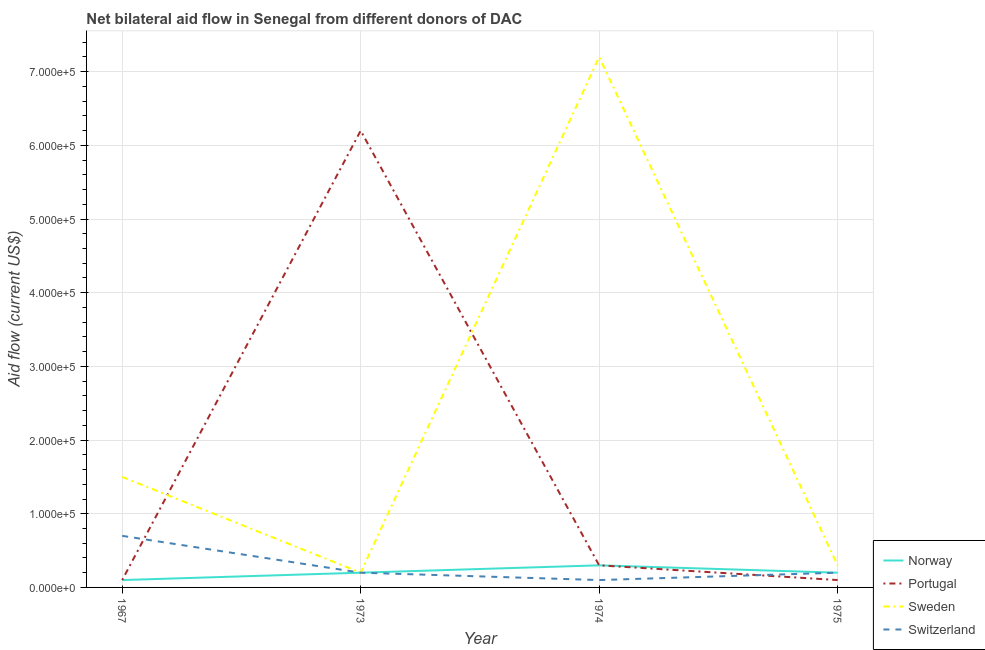What is the amount of aid given by sweden in 1975?
Provide a short and direct response. 3.00e+04. Across all years, what is the maximum amount of aid given by sweden?
Your response must be concise. 7.20e+05. Across all years, what is the minimum amount of aid given by sweden?
Your answer should be compact. 2.00e+04. In which year was the amount of aid given by norway maximum?
Your response must be concise. 1974. In which year was the amount of aid given by switzerland minimum?
Your answer should be very brief. 1974. What is the total amount of aid given by switzerland in the graph?
Provide a succinct answer. 1.20e+05. What is the difference between the amount of aid given by switzerland in 1973 and that in 1975?
Make the answer very short. 0. What is the difference between the amount of aid given by norway in 1967 and the amount of aid given by switzerland in 1975?
Ensure brevity in your answer.  -10000. In the year 1975, what is the difference between the amount of aid given by sweden and amount of aid given by switzerland?
Give a very brief answer. 10000. What is the ratio of the amount of aid given by sweden in 1967 to that in 1973?
Keep it short and to the point. 7.5. Is the amount of aid given by sweden in 1967 less than that in 1974?
Offer a terse response. Yes. Is the difference between the amount of aid given by portugal in 1967 and 1975 greater than the difference between the amount of aid given by norway in 1967 and 1975?
Provide a short and direct response. Yes. What is the difference between the highest and the second highest amount of aid given by switzerland?
Your answer should be very brief. 5.00e+04. What is the difference between the highest and the lowest amount of aid given by sweden?
Your response must be concise. 7.00e+05. Is it the case that in every year, the sum of the amount of aid given by sweden and amount of aid given by portugal is greater than the sum of amount of aid given by switzerland and amount of aid given by norway?
Offer a terse response. Yes. Is it the case that in every year, the sum of the amount of aid given by norway and amount of aid given by portugal is greater than the amount of aid given by sweden?
Provide a succinct answer. No. Is the amount of aid given by portugal strictly greater than the amount of aid given by norway over the years?
Your answer should be very brief. No. Is the amount of aid given by switzerland strictly less than the amount of aid given by portugal over the years?
Make the answer very short. No. How many lines are there?
Offer a very short reply. 4. What is the difference between two consecutive major ticks on the Y-axis?
Offer a terse response. 1.00e+05. Are the values on the major ticks of Y-axis written in scientific E-notation?
Your answer should be very brief. Yes. Does the graph contain grids?
Your response must be concise. Yes. Where does the legend appear in the graph?
Offer a terse response. Bottom right. How many legend labels are there?
Ensure brevity in your answer.  4. How are the legend labels stacked?
Make the answer very short. Vertical. What is the title of the graph?
Offer a very short reply. Net bilateral aid flow in Senegal from different donors of DAC. What is the label or title of the Y-axis?
Your answer should be very brief. Aid flow (current US$). What is the Aid flow (current US$) of Norway in 1967?
Make the answer very short. 10000. What is the Aid flow (current US$) in Sweden in 1967?
Give a very brief answer. 1.50e+05. What is the Aid flow (current US$) in Norway in 1973?
Offer a very short reply. 2.00e+04. What is the Aid flow (current US$) in Portugal in 1973?
Your response must be concise. 6.20e+05. What is the Aid flow (current US$) of Sweden in 1973?
Your answer should be very brief. 2.00e+04. What is the Aid flow (current US$) in Norway in 1974?
Offer a very short reply. 3.00e+04. What is the Aid flow (current US$) in Sweden in 1974?
Offer a very short reply. 7.20e+05. What is the Aid flow (current US$) of Switzerland in 1974?
Give a very brief answer. 10000. What is the Aid flow (current US$) of Portugal in 1975?
Provide a short and direct response. 10000. Across all years, what is the maximum Aid flow (current US$) of Portugal?
Keep it short and to the point. 6.20e+05. Across all years, what is the maximum Aid flow (current US$) of Sweden?
Your answer should be very brief. 7.20e+05. Across all years, what is the maximum Aid flow (current US$) of Switzerland?
Ensure brevity in your answer.  7.00e+04. Across all years, what is the minimum Aid flow (current US$) in Sweden?
Your response must be concise. 2.00e+04. What is the total Aid flow (current US$) in Norway in the graph?
Offer a very short reply. 8.00e+04. What is the total Aid flow (current US$) of Portugal in the graph?
Your answer should be compact. 6.70e+05. What is the total Aid flow (current US$) of Sweden in the graph?
Provide a short and direct response. 9.20e+05. What is the total Aid flow (current US$) of Switzerland in the graph?
Give a very brief answer. 1.20e+05. What is the difference between the Aid flow (current US$) in Portugal in 1967 and that in 1973?
Make the answer very short. -6.10e+05. What is the difference between the Aid flow (current US$) of Switzerland in 1967 and that in 1973?
Offer a terse response. 5.00e+04. What is the difference between the Aid flow (current US$) in Norway in 1967 and that in 1974?
Offer a very short reply. -2.00e+04. What is the difference between the Aid flow (current US$) of Portugal in 1967 and that in 1974?
Give a very brief answer. -2.00e+04. What is the difference between the Aid flow (current US$) of Sweden in 1967 and that in 1974?
Make the answer very short. -5.70e+05. What is the difference between the Aid flow (current US$) of Norway in 1967 and that in 1975?
Provide a succinct answer. -10000. What is the difference between the Aid flow (current US$) of Portugal in 1967 and that in 1975?
Make the answer very short. 0. What is the difference between the Aid flow (current US$) in Portugal in 1973 and that in 1974?
Ensure brevity in your answer.  5.90e+05. What is the difference between the Aid flow (current US$) in Sweden in 1973 and that in 1974?
Your answer should be very brief. -7.00e+05. What is the difference between the Aid flow (current US$) of Norway in 1973 and that in 1975?
Your answer should be very brief. 0. What is the difference between the Aid flow (current US$) of Sweden in 1973 and that in 1975?
Provide a short and direct response. -10000. What is the difference between the Aid flow (current US$) in Norway in 1974 and that in 1975?
Offer a terse response. 10000. What is the difference between the Aid flow (current US$) of Portugal in 1974 and that in 1975?
Provide a succinct answer. 2.00e+04. What is the difference between the Aid flow (current US$) in Sweden in 1974 and that in 1975?
Provide a succinct answer. 6.90e+05. What is the difference between the Aid flow (current US$) in Norway in 1967 and the Aid flow (current US$) in Portugal in 1973?
Ensure brevity in your answer.  -6.10e+05. What is the difference between the Aid flow (current US$) of Norway in 1967 and the Aid flow (current US$) of Sweden in 1973?
Make the answer very short. -10000. What is the difference between the Aid flow (current US$) of Norway in 1967 and the Aid flow (current US$) of Switzerland in 1973?
Ensure brevity in your answer.  -10000. What is the difference between the Aid flow (current US$) in Sweden in 1967 and the Aid flow (current US$) in Switzerland in 1973?
Your answer should be very brief. 1.30e+05. What is the difference between the Aid flow (current US$) in Norway in 1967 and the Aid flow (current US$) in Portugal in 1974?
Provide a succinct answer. -2.00e+04. What is the difference between the Aid flow (current US$) of Norway in 1967 and the Aid flow (current US$) of Sweden in 1974?
Give a very brief answer. -7.10e+05. What is the difference between the Aid flow (current US$) in Portugal in 1967 and the Aid flow (current US$) in Sweden in 1974?
Make the answer very short. -7.10e+05. What is the difference between the Aid flow (current US$) in Norway in 1967 and the Aid flow (current US$) in Switzerland in 1975?
Offer a terse response. -10000. What is the difference between the Aid flow (current US$) of Portugal in 1967 and the Aid flow (current US$) of Sweden in 1975?
Keep it short and to the point. -2.00e+04. What is the difference between the Aid flow (current US$) of Portugal in 1967 and the Aid flow (current US$) of Switzerland in 1975?
Keep it short and to the point. -10000. What is the difference between the Aid flow (current US$) of Norway in 1973 and the Aid flow (current US$) of Portugal in 1974?
Your response must be concise. -10000. What is the difference between the Aid flow (current US$) in Norway in 1973 and the Aid flow (current US$) in Sweden in 1974?
Provide a short and direct response. -7.00e+05. What is the difference between the Aid flow (current US$) in Sweden in 1973 and the Aid flow (current US$) in Switzerland in 1974?
Make the answer very short. 10000. What is the difference between the Aid flow (current US$) in Norway in 1973 and the Aid flow (current US$) in Portugal in 1975?
Keep it short and to the point. 10000. What is the difference between the Aid flow (current US$) in Norway in 1973 and the Aid flow (current US$) in Sweden in 1975?
Offer a very short reply. -10000. What is the difference between the Aid flow (current US$) of Norway in 1973 and the Aid flow (current US$) of Switzerland in 1975?
Make the answer very short. 0. What is the difference between the Aid flow (current US$) of Portugal in 1973 and the Aid flow (current US$) of Sweden in 1975?
Offer a terse response. 5.90e+05. What is the difference between the Aid flow (current US$) of Norway in 1974 and the Aid flow (current US$) of Portugal in 1975?
Your response must be concise. 2.00e+04. What is the difference between the Aid flow (current US$) of Norway in 1974 and the Aid flow (current US$) of Switzerland in 1975?
Provide a succinct answer. 10000. What is the difference between the Aid flow (current US$) in Portugal in 1974 and the Aid flow (current US$) in Sweden in 1975?
Provide a succinct answer. 0. What is the average Aid flow (current US$) of Portugal per year?
Offer a terse response. 1.68e+05. What is the average Aid flow (current US$) of Switzerland per year?
Provide a short and direct response. 3.00e+04. In the year 1967, what is the difference between the Aid flow (current US$) of Norway and Aid flow (current US$) of Sweden?
Ensure brevity in your answer.  -1.40e+05. In the year 1967, what is the difference between the Aid flow (current US$) of Portugal and Aid flow (current US$) of Switzerland?
Provide a short and direct response. -6.00e+04. In the year 1973, what is the difference between the Aid flow (current US$) in Norway and Aid flow (current US$) in Portugal?
Keep it short and to the point. -6.00e+05. In the year 1973, what is the difference between the Aid flow (current US$) in Norway and Aid flow (current US$) in Sweden?
Offer a very short reply. 0. In the year 1974, what is the difference between the Aid flow (current US$) in Norway and Aid flow (current US$) in Sweden?
Your answer should be compact. -6.90e+05. In the year 1974, what is the difference between the Aid flow (current US$) in Norway and Aid flow (current US$) in Switzerland?
Ensure brevity in your answer.  2.00e+04. In the year 1974, what is the difference between the Aid flow (current US$) of Portugal and Aid flow (current US$) of Sweden?
Your response must be concise. -6.90e+05. In the year 1974, what is the difference between the Aid flow (current US$) in Portugal and Aid flow (current US$) in Switzerland?
Provide a short and direct response. 2.00e+04. In the year 1974, what is the difference between the Aid flow (current US$) of Sweden and Aid flow (current US$) of Switzerland?
Offer a terse response. 7.10e+05. In the year 1975, what is the difference between the Aid flow (current US$) of Norway and Aid flow (current US$) of Portugal?
Your answer should be compact. 10000. In the year 1975, what is the difference between the Aid flow (current US$) of Norway and Aid flow (current US$) of Sweden?
Make the answer very short. -10000. In the year 1975, what is the difference between the Aid flow (current US$) of Portugal and Aid flow (current US$) of Sweden?
Offer a very short reply. -2.00e+04. What is the ratio of the Aid flow (current US$) of Norway in 1967 to that in 1973?
Provide a succinct answer. 0.5. What is the ratio of the Aid flow (current US$) in Portugal in 1967 to that in 1973?
Provide a short and direct response. 0.02. What is the ratio of the Aid flow (current US$) of Norway in 1967 to that in 1974?
Your answer should be compact. 0.33. What is the ratio of the Aid flow (current US$) of Portugal in 1967 to that in 1974?
Your answer should be very brief. 0.33. What is the ratio of the Aid flow (current US$) of Sweden in 1967 to that in 1974?
Keep it short and to the point. 0.21. What is the ratio of the Aid flow (current US$) in Norway in 1967 to that in 1975?
Give a very brief answer. 0.5. What is the ratio of the Aid flow (current US$) of Portugal in 1967 to that in 1975?
Your response must be concise. 1. What is the ratio of the Aid flow (current US$) in Sweden in 1967 to that in 1975?
Provide a succinct answer. 5. What is the ratio of the Aid flow (current US$) of Portugal in 1973 to that in 1974?
Give a very brief answer. 20.67. What is the ratio of the Aid flow (current US$) of Sweden in 1973 to that in 1974?
Keep it short and to the point. 0.03. What is the ratio of the Aid flow (current US$) in Norway in 1973 to that in 1975?
Offer a very short reply. 1. What is the ratio of the Aid flow (current US$) in Portugal in 1973 to that in 1975?
Provide a succinct answer. 62. What is the ratio of the Aid flow (current US$) in Switzerland in 1973 to that in 1975?
Offer a very short reply. 1. What is the ratio of the Aid flow (current US$) of Norway in 1974 to that in 1975?
Provide a succinct answer. 1.5. What is the ratio of the Aid flow (current US$) of Portugal in 1974 to that in 1975?
Ensure brevity in your answer.  3. What is the difference between the highest and the second highest Aid flow (current US$) of Portugal?
Keep it short and to the point. 5.90e+05. What is the difference between the highest and the second highest Aid flow (current US$) of Sweden?
Keep it short and to the point. 5.70e+05. What is the difference between the highest and the second highest Aid flow (current US$) of Switzerland?
Your answer should be compact. 5.00e+04. What is the difference between the highest and the lowest Aid flow (current US$) of Portugal?
Give a very brief answer. 6.10e+05. 